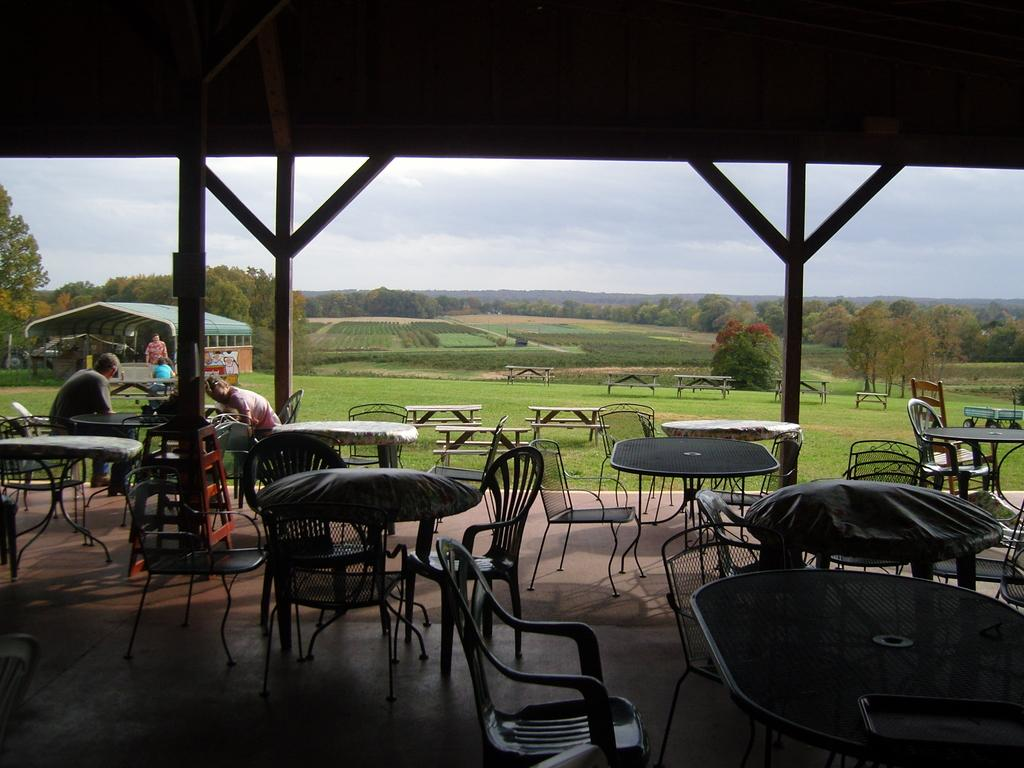What can be seen in the sky in the image? There is a sky in the image, but no specific details about the sky are provided. What type of plant is visible in the image? There is a tree in the image. What type of ground cover is present in the image? There is grass in the image. What type of furniture is present in the image? There are chairs and tables in the image. How many people are sitting in the image? Two people are sitting on chairs in the image. What color is the tramp that the people are bouncing on in the image? There is no tramp present in the image; the people are sitting on chairs. What type of fruit is the orange that the tree is bearing in the image? There is no orange or fruit mentioned in the image; the tree is not described in detail. 